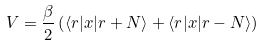Convert formula to latex. <formula><loc_0><loc_0><loc_500><loc_500>V = \frac { \beta } { 2 } \left ( \langle r | x | r + N \rangle + \langle r | x | r - N \rangle \right )</formula> 